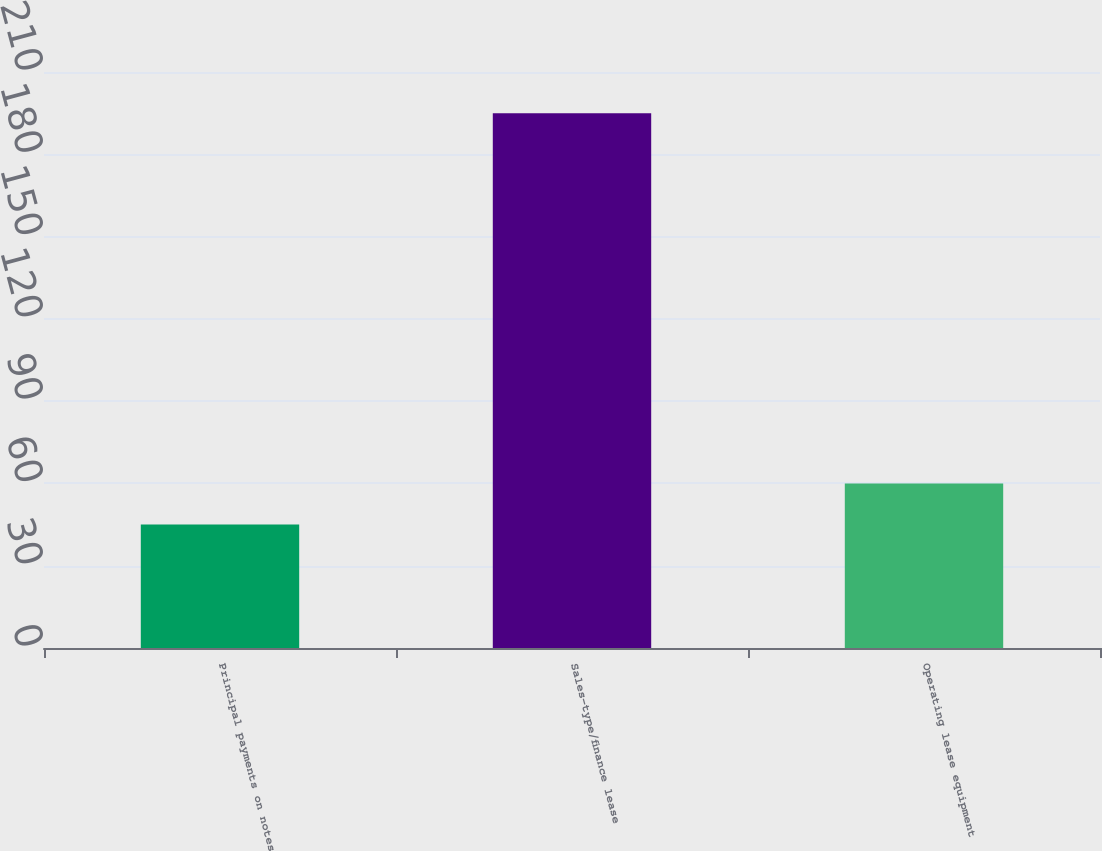Convert chart to OTSL. <chart><loc_0><loc_0><loc_500><loc_500><bar_chart><fcel>Principal payments on notes<fcel>Sales-type/finance lease<fcel>Operating lease equipment<nl><fcel>45<fcel>195<fcel>60<nl></chart> 